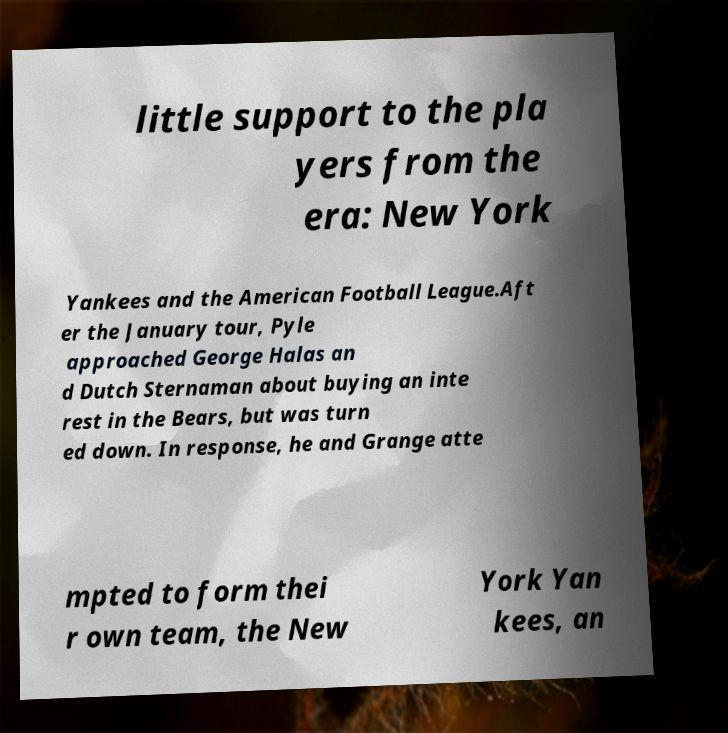There's text embedded in this image that I need extracted. Can you transcribe it verbatim? little support to the pla yers from the era: New York Yankees and the American Football League.Aft er the January tour, Pyle approached George Halas an d Dutch Sternaman about buying an inte rest in the Bears, but was turn ed down. In response, he and Grange atte mpted to form thei r own team, the New York Yan kees, an 